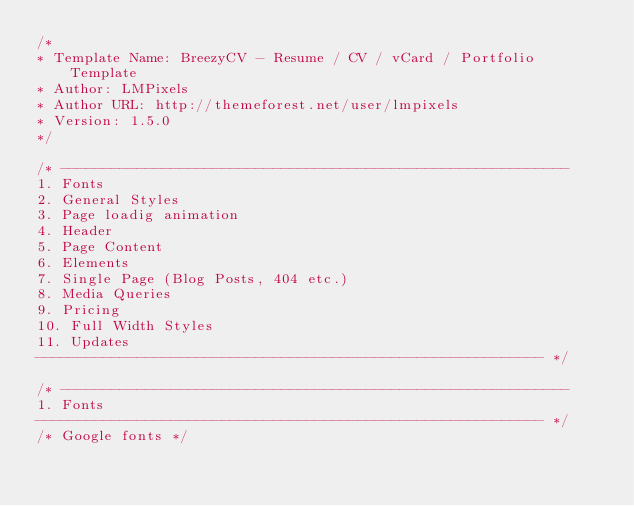Convert code to text. <code><loc_0><loc_0><loc_500><loc_500><_CSS_>/*
* Template Name: BreezyCV - Resume / CV / vCard / Portfolio Template
* Author: LMPixels
* Author URL: http://themeforest.net/user/lmpixels
* Version: 1.5.0
*/

/* ------------------------------------------------------------
1. Fonts
2. General Styles
3. Page loadig animation
4. Header
5. Page Content
6. Elements
7. Single Page (Blog Posts, 404 etc.)
8. Media Queries
9. Pricing
10. Full Width Styles
11. Updates
------------------------------------------------------------ */

/* ------------------------------------------------------------
1. Fonts
------------------------------------------------------------ */
/* Google fonts */</code> 